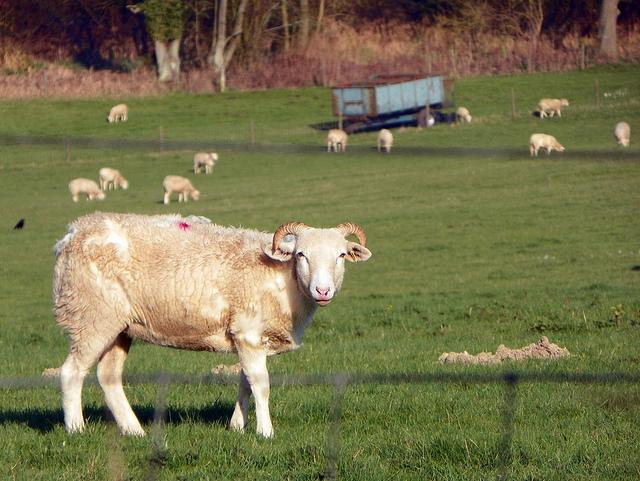Why do sheep have horns? defense 